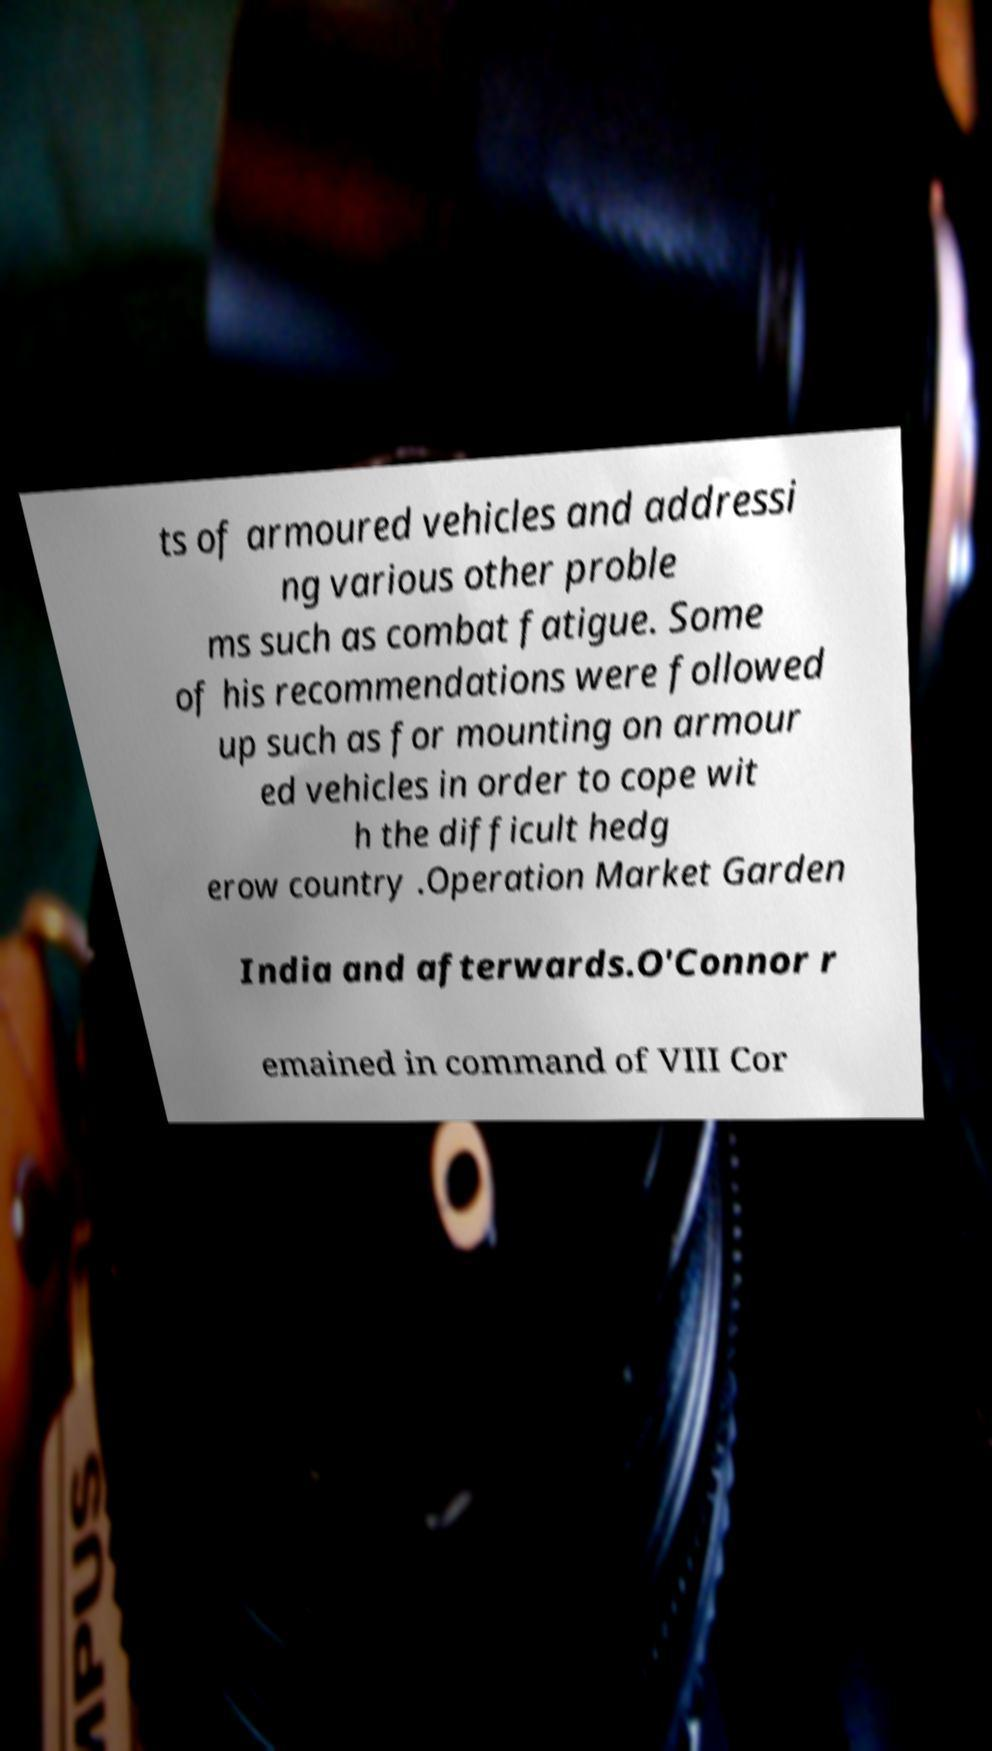For documentation purposes, I need the text within this image transcribed. Could you provide that? ts of armoured vehicles and addressi ng various other proble ms such as combat fatigue. Some of his recommendations were followed up such as for mounting on armour ed vehicles in order to cope wit h the difficult hedg erow country .Operation Market Garden India and afterwards.O'Connor r emained in command of VIII Cor 